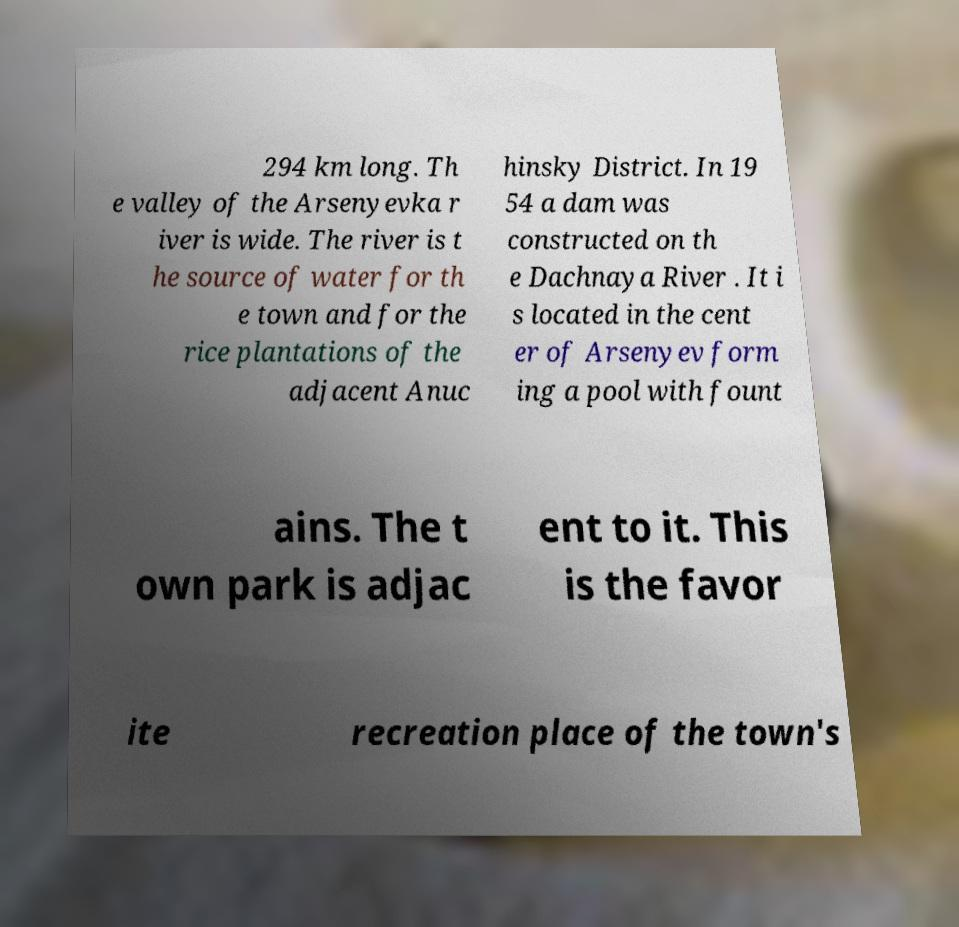Could you assist in decoding the text presented in this image and type it out clearly? 294 km long. Th e valley of the Arsenyevka r iver is wide. The river is t he source of water for th e town and for the rice plantations of the adjacent Anuc hinsky District. In 19 54 a dam was constructed on th e Dachnaya River . It i s located in the cent er of Arsenyev form ing a pool with fount ains. The t own park is adjac ent to it. This is the favor ite recreation place of the town's 